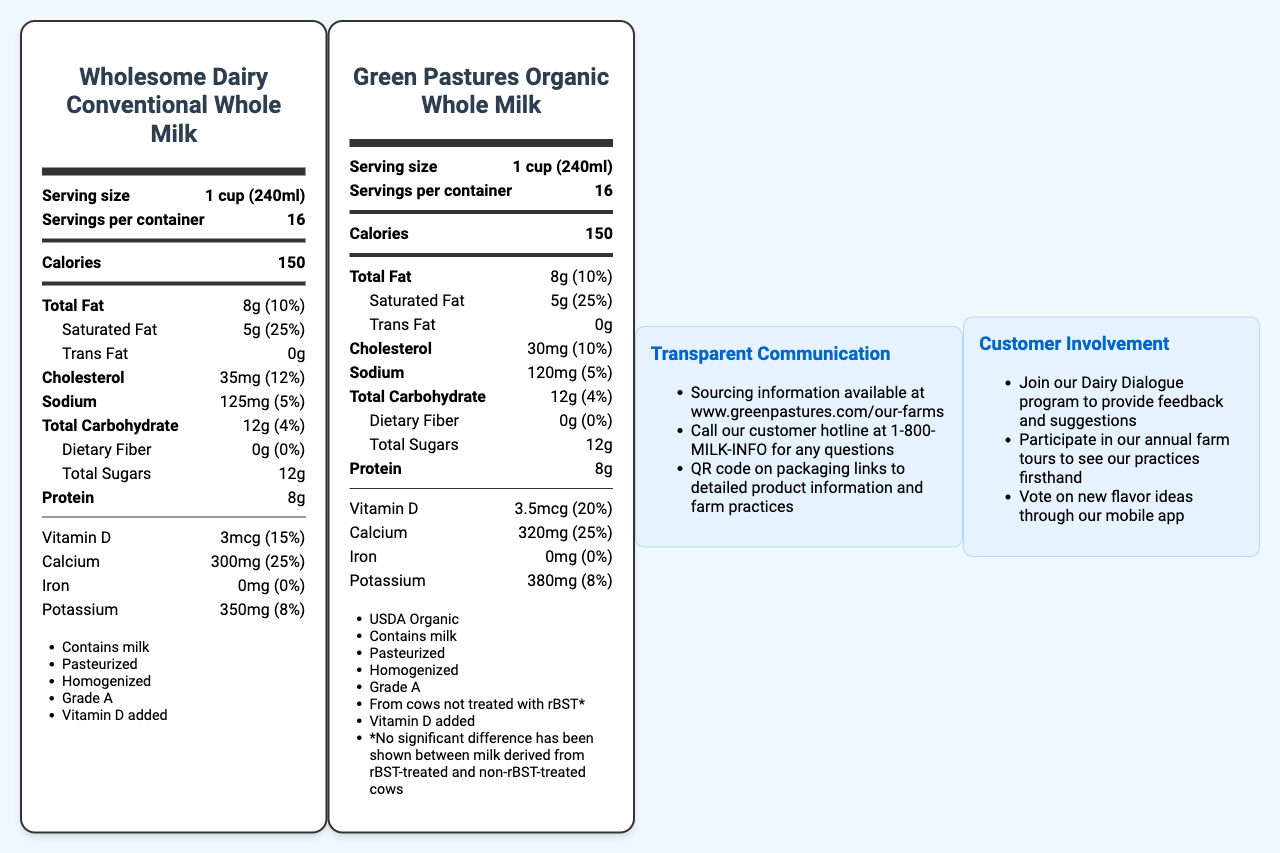what is the serving size for both types of whole milk? The serving size is explicitly mentioned as "1 cup (240ml)" for both conventional and organic whole milk in the document.
Answer: 1 cup (240ml) how many calories are in a serving of conventional whole milk? The document states that conventional whole milk has 150 calories per serving.
Answer: 150 calories how much cholesterol is in organic whole milk? For organic whole milk, the document lists 30mg of cholesterol, which amounts to 10% of the daily value.
Answer: 30mg (10% DV) which type of milk has more vitamin D? The document indicates that the organic milk has 3.5 micrograms of vitamin D, whereas the conventional milk has 3 micrograms.
Answer: Green Pastures Organic Whole Milk what is the amount of total fat in both types of milk? Both conventional and organic whole milk contain 8 grams of total fat, as shown in the document.
Answer: 8g which milk contains more calcium? A. Wholesome Dairy Conventional Whole Milk B. Green Pastures Organic Whole Milk C. Both contain the same amount The organic milk contains 320mg of calcium whereas the conventional milk contains 300mg according to the document.
Answer: B what is the percentage of daily value for saturated fat in both types of milk? A. 5% B. 10% C. 20% D. 25% The document shows that both types of milk have a 25% daily value for saturated fat.
Answer: D which milk is labeled as USDA Organic? A. Wholesome Dairy Conventional Whole Milk B. Green Pastures Organic Whole Milk C. Both Only the Green Pastures Organic Whole Milk is labeled as USDA Organic, as indicated in the 'additional info' section.
Answer: B does conventional whole milk contain any fiber? The document states that both types of milk have 0g of dietary fiber.
Answer: No what is the main difference in the sourcing information of the two types of milk? The document specifically mentions that Green Pastures Organic Whole Milk has sourcing information available at a website and through a QR code on the packaging.
Answer: Organic milk provides sourcing information via a website and a QR code on the packaging. summarize the main nutritional differences between conventional and organic whole milk presented in the document. The document shows that both types of milk have the same amounts of calories, total fat, saturated fat, total carbohydrates, sugars, protein, and iron. However, organic whole milk has lower cholesterol (30mg vs 35mg), higher vitamin D (3.5mcg vs 3mcg), more calcium (320mg vs 300mg), and more potassium (380mg vs 350mg).
Answer: Mainly, organic whole milk contains slightly less cholesterol and slightly more vitamin D, calcium, and potassium than conventional whole milk. what are the benefits provided by the Dairy Dialogue program mentioned in the document? The document mentions the Dairy Dialogue program to provide feedback and suggestions but does not detail its specific benefits.
Answer: Not enough information 